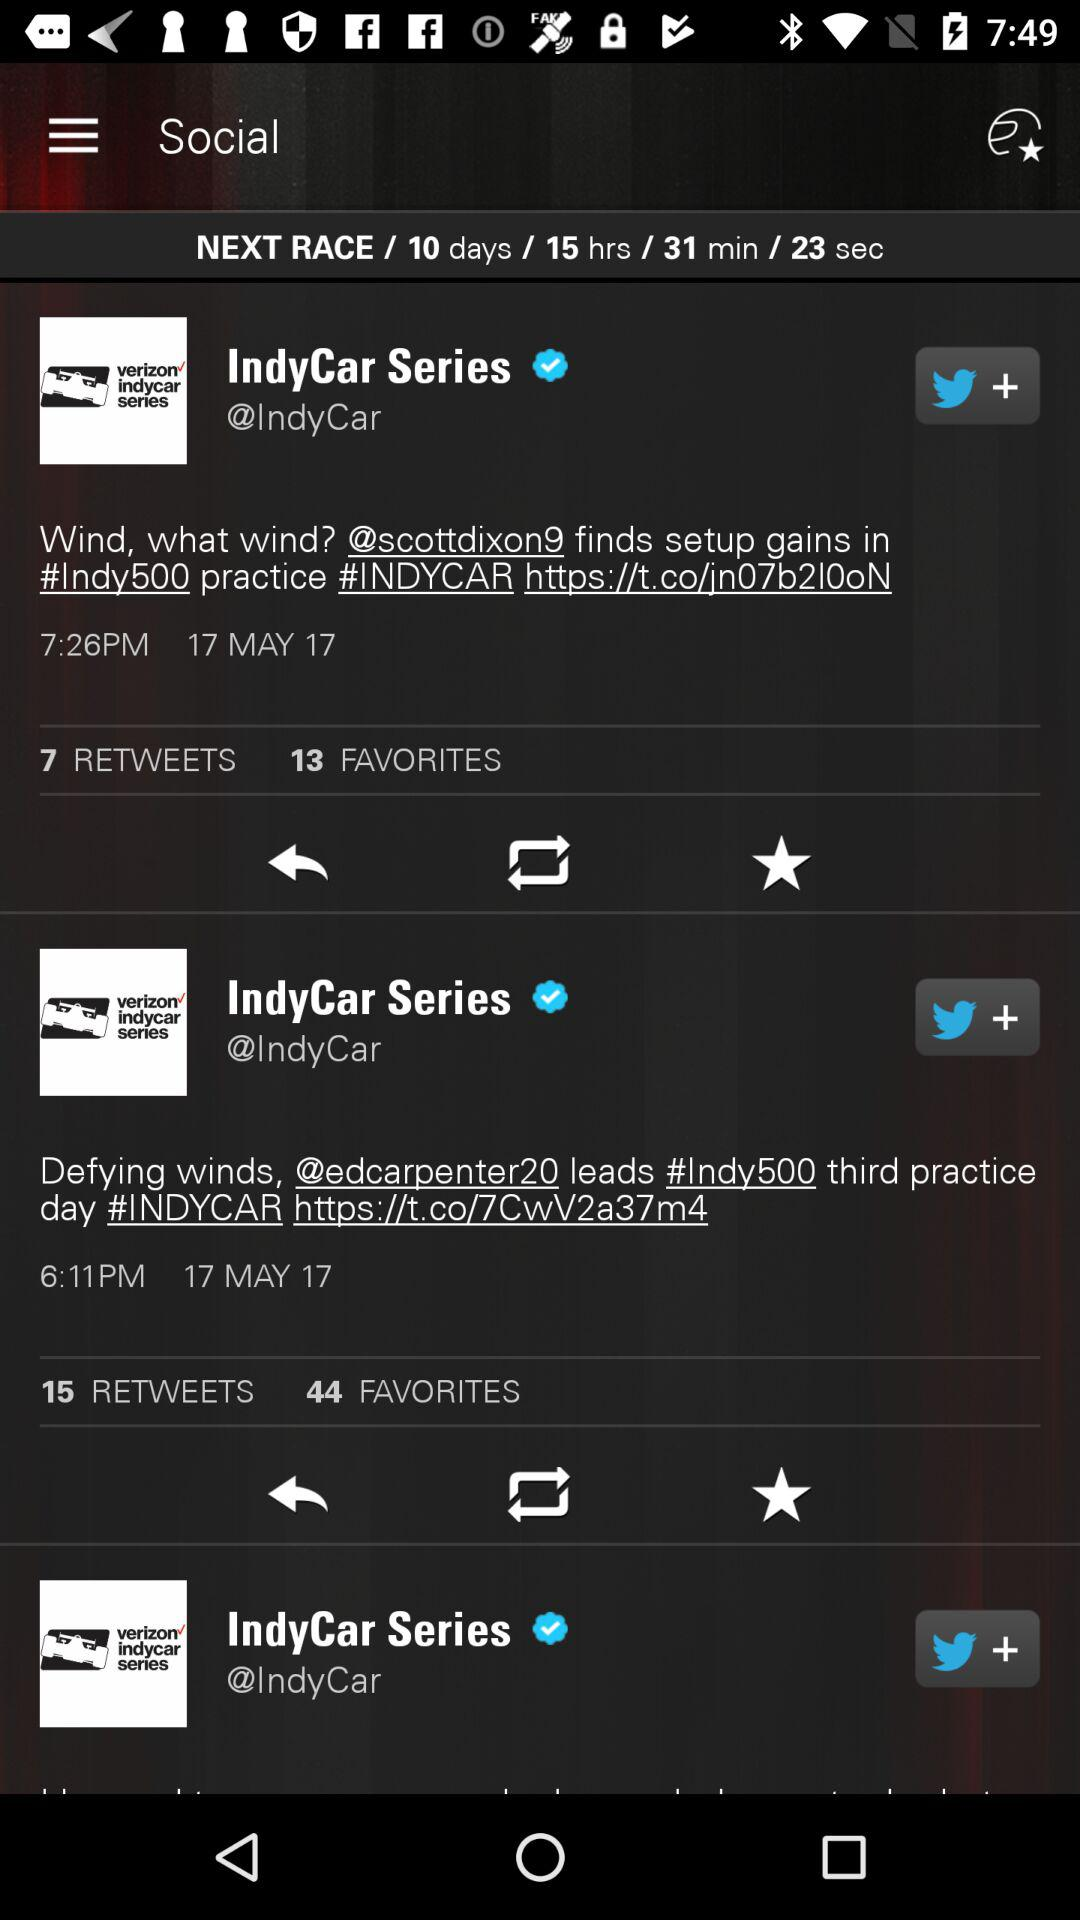What is the time of the tweet with 7 retweets? The time of the tweet with 7 retweets is 7:26 p.m. 